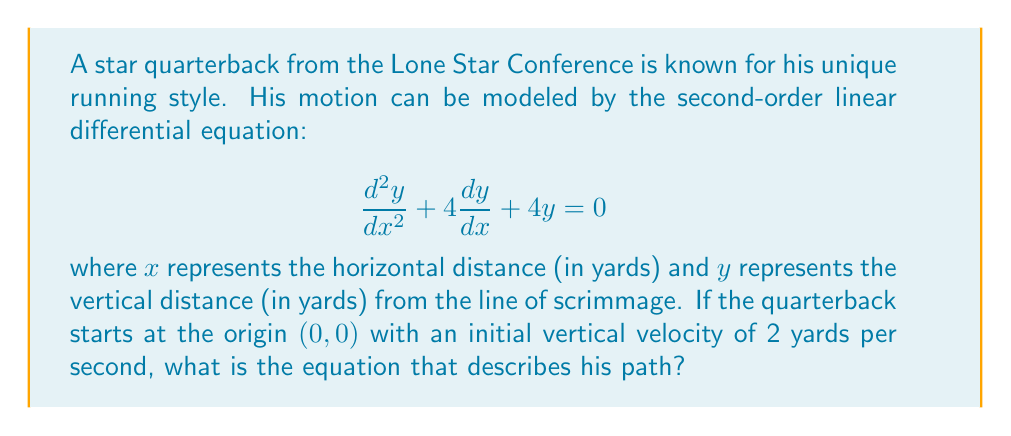Teach me how to tackle this problem. To solve this problem, we need to follow these steps:

1) The general solution for this second-order linear differential equation is:

   $$y = (C_1 + C_2x)e^{-2x}$$

   where $C_1$ and $C_2$ are constants we need to determine.

2) We're given two initial conditions:
   - The quarterback starts at the origin: $y(0) = 0$
   - The initial vertical velocity is 2 yards per second: $y'(0) = 2$

3) Let's apply the first condition:

   $y(0) = (C_1 + C_2 \cdot 0)e^{-2 \cdot 0} = C_1 = 0$

4) Now, let's find $y'(x)$:

   $$y'(x) = (-2C_1 - 2C_2x + C_2)e^{-2x}$$

5) Apply the second condition:

   $y'(0) = (-2C_1 + C_2)e^0 = C_2 = 2$

6) Now we have $C_1 = 0$ and $C_2 = 2$. Substituting these into our general solution:

   $$y = (0 + 2x)e^{-2x} = 2xe^{-2x}$$

This equation describes the path of the quarterback's motion.
Answer: $y = 2xe^{-2x}$ 